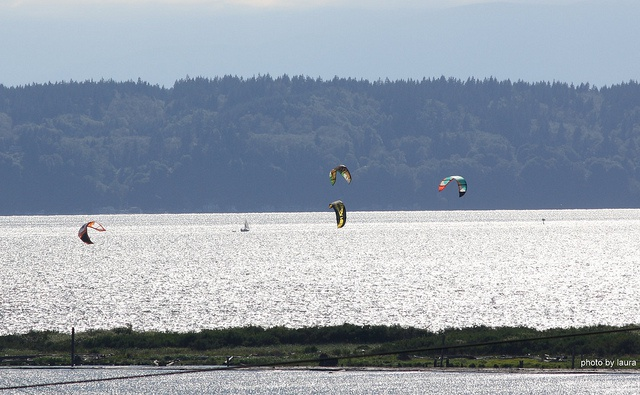Describe the objects in this image and their specific colors. I can see kite in lightgray, gray, and teal tones, kite in lightgray, black, gray, darkgreen, and tan tones, kite in lightgray, gray, black, olive, and darkgray tones, kite in lightgray, black, gray, and maroon tones, and boat in lightgray, darkgray, and gray tones in this image. 